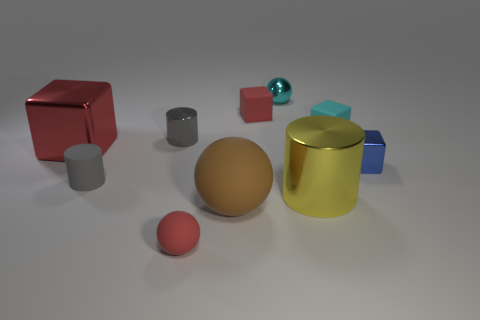Are there more matte cubes right of the large cylinder than small rubber cylinders that are to the right of the small gray metallic cylinder?
Make the answer very short. Yes. What number of other objects are the same size as the brown ball?
Provide a succinct answer. 2. What is the size of the red thing on the left side of the metal cylinder that is on the left side of the cyan metal thing?
Your answer should be very brief. Large. How many big objects are cyan spheres or yellow rubber cylinders?
Your answer should be compact. 0. What is the size of the red block that is on the left side of the tiny gray cylinder right of the tiny cylinder that is in front of the big red metal thing?
Keep it short and to the point. Large. Is there any other thing that has the same color as the large ball?
Provide a succinct answer. No. What is the cyan object that is left of the shiny cylinder that is in front of the big metal object behind the yellow object made of?
Provide a short and direct response. Metal. Does the blue metal thing have the same shape as the large red thing?
Keep it short and to the point. Yes. How many things are both behind the red rubber ball and in front of the blue shiny cube?
Offer a terse response. 3. There is a metal cube in front of the large object that is to the left of the large brown thing; what color is it?
Offer a very short reply. Blue. 